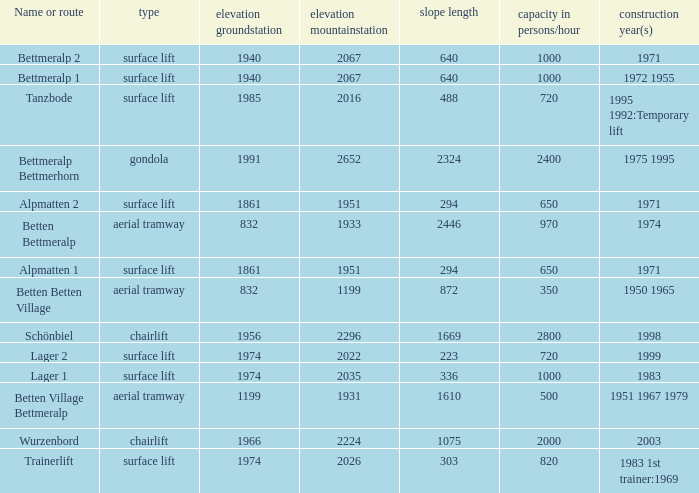Which elevation groundstation has a capacity in persons/hour larger than 820, and a Name or route of lager 1, and a slope length smaller than 336? None. 